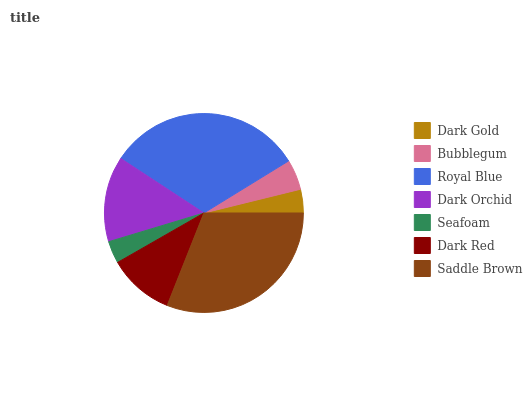Is Seafoam the minimum?
Answer yes or no. Yes. Is Royal Blue the maximum?
Answer yes or no. Yes. Is Bubblegum the minimum?
Answer yes or no. No. Is Bubblegum the maximum?
Answer yes or no. No. Is Bubblegum greater than Dark Gold?
Answer yes or no. Yes. Is Dark Gold less than Bubblegum?
Answer yes or no. Yes. Is Dark Gold greater than Bubblegum?
Answer yes or no. No. Is Bubblegum less than Dark Gold?
Answer yes or no. No. Is Dark Red the high median?
Answer yes or no. Yes. Is Dark Red the low median?
Answer yes or no. Yes. Is Saddle Brown the high median?
Answer yes or no. No. Is Saddle Brown the low median?
Answer yes or no. No. 